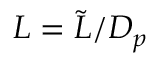Convert formula to latex. <formula><loc_0><loc_0><loc_500><loc_500>L = { \tilde { L } } / { D _ { p } }</formula> 